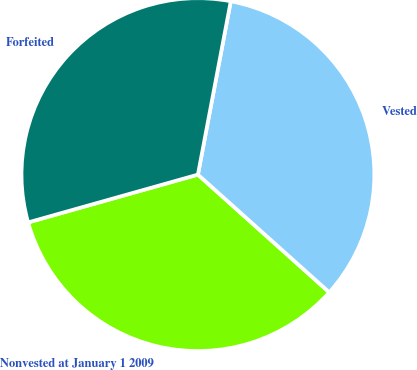Convert chart to OTSL. <chart><loc_0><loc_0><loc_500><loc_500><pie_chart><fcel>Nonvested at January 1 2009<fcel>Vested<fcel>Forfeited<nl><fcel>34.0%<fcel>33.65%<fcel>32.35%<nl></chart> 